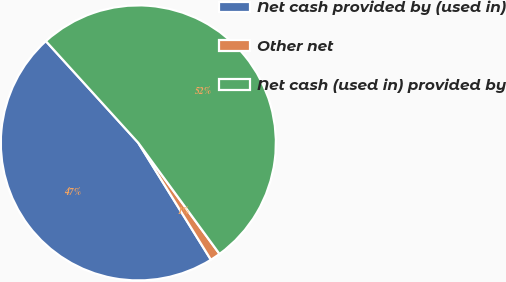Convert chart to OTSL. <chart><loc_0><loc_0><loc_500><loc_500><pie_chart><fcel>Net cash provided by (used in)<fcel>Other net<fcel>Net cash (used in) provided by<nl><fcel>47.11%<fcel>1.2%<fcel>51.7%<nl></chart> 